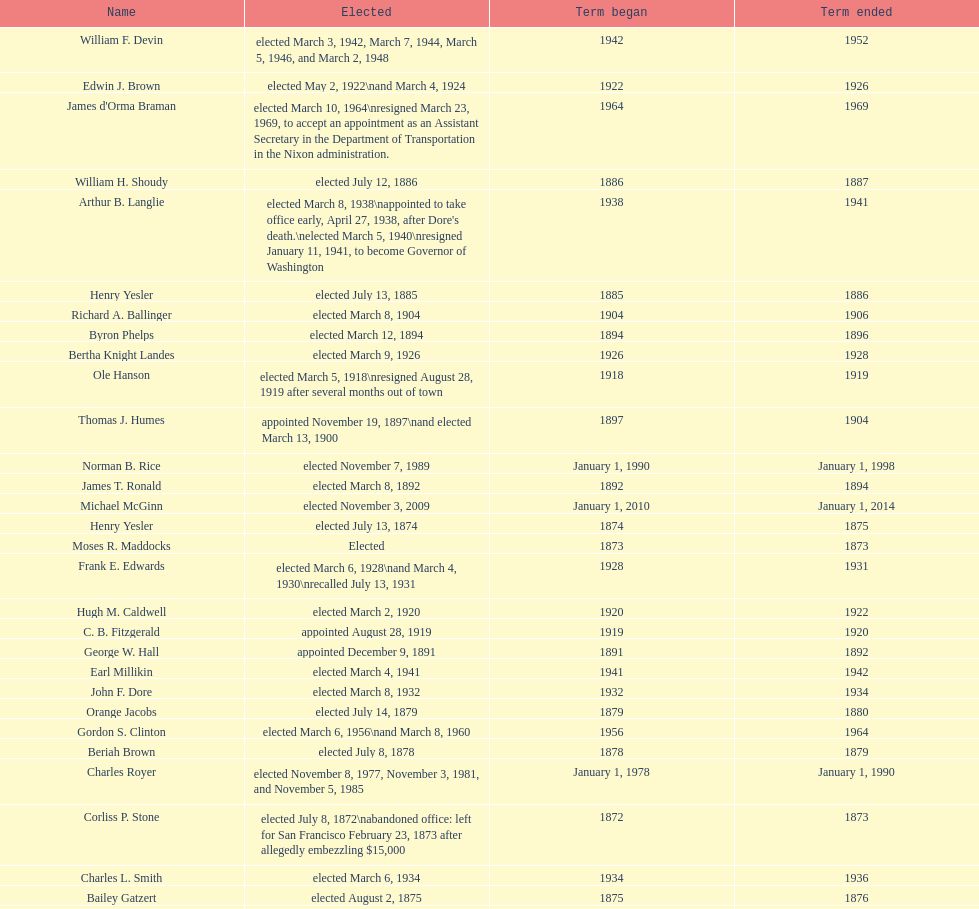Who was the only person elected in 1871? John T. Jordan. 